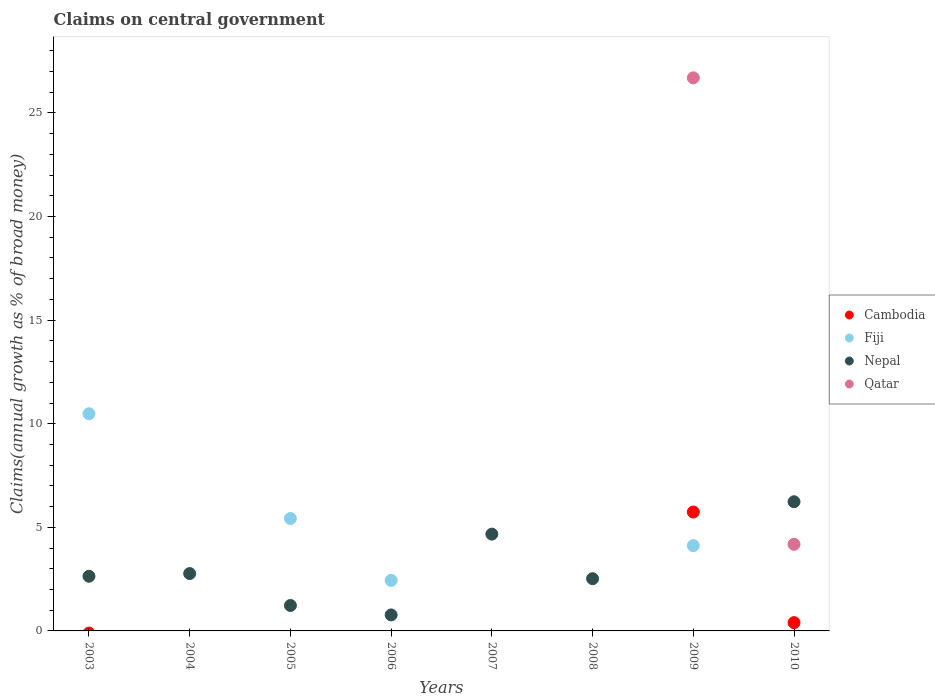Is the number of dotlines equal to the number of legend labels?
Your response must be concise. No. What is the percentage of broad money claimed on centeral government in Nepal in 2006?
Your answer should be very brief. 0.77. Across all years, what is the maximum percentage of broad money claimed on centeral government in Cambodia?
Your answer should be very brief. 5.74. Across all years, what is the minimum percentage of broad money claimed on centeral government in Fiji?
Offer a very short reply. 0. In which year was the percentage of broad money claimed on centeral government in Cambodia maximum?
Your answer should be very brief. 2009. What is the total percentage of broad money claimed on centeral government in Nepal in the graph?
Your answer should be very brief. 20.83. What is the difference between the percentage of broad money claimed on centeral government in Fiji in 2003 and that in 2009?
Offer a terse response. 6.37. What is the average percentage of broad money claimed on centeral government in Cambodia per year?
Make the answer very short. 0.77. What is the ratio of the percentage of broad money claimed on centeral government in Nepal in 2006 to that in 2007?
Offer a terse response. 0.17. What is the difference between the highest and the second highest percentage of broad money claimed on centeral government in Nepal?
Make the answer very short. 1.56. What is the difference between the highest and the lowest percentage of broad money claimed on centeral government in Cambodia?
Offer a very short reply. 5.74. Is it the case that in every year, the sum of the percentage of broad money claimed on centeral government in Qatar and percentage of broad money claimed on centeral government in Nepal  is greater than the sum of percentage of broad money claimed on centeral government in Fiji and percentage of broad money claimed on centeral government in Cambodia?
Offer a terse response. No. Does the percentage of broad money claimed on centeral government in Fiji monotonically increase over the years?
Your answer should be compact. No. Is the percentage of broad money claimed on centeral government in Nepal strictly greater than the percentage of broad money claimed on centeral government in Fiji over the years?
Your response must be concise. No. Is the percentage of broad money claimed on centeral government in Qatar strictly less than the percentage of broad money claimed on centeral government in Nepal over the years?
Keep it short and to the point. No. How many years are there in the graph?
Your answer should be very brief. 8. What is the difference between two consecutive major ticks on the Y-axis?
Your response must be concise. 5. Where does the legend appear in the graph?
Your answer should be compact. Center right. How are the legend labels stacked?
Provide a short and direct response. Vertical. What is the title of the graph?
Give a very brief answer. Claims on central government. Does "Korea (Democratic)" appear as one of the legend labels in the graph?
Offer a terse response. No. What is the label or title of the X-axis?
Ensure brevity in your answer.  Years. What is the label or title of the Y-axis?
Offer a very short reply. Claims(annual growth as % of broad money). What is the Claims(annual growth as % of broad money) in Fiji in 2003?
Give a very brief answer. 10.48. What is the Claims(annual growth as % of broad money) in Nepal in 2003?
Provide a short and direct response. 2.64. What is the Claims(annual growth as % of broad money) in Nepal in 2004?
Give a very brief answer. 2.77. What is the Claims(annual growth as % of broad money) of Qatar in 2004?
Offer a very short reply. 0. What is the Claims(annual growth as % of broad money) of Fiji in 2005?
Your answer should be compact. 5.42. What is the Claims(annual growth as % of broad money) of Nepal in 2005?
Offer a terse response. 1.23. What is the Claims(annual growth as % of broad money) of Fiji in 2006?
Offer a terse response. 2.44. What is the Claims(annual growth as % of broad money) in Nepal in 2006?
Offer a terse response. 0.77. What is the Claims(annual growth as % of broad money) in Cambodia in 2007?
Offer a terse response. 0. What is the Claims(annual growth as % of broad money) in Fiji in 2007?
Make the answer very short. 0. What is the Claims(annual growth as % of broad money) of Nepal in 2007?
Make the answer very short. 4.67. What is the Claims(annual growth as % of broad money) of Qatar in 2007?
Your response must be concise. 0. What is the Claims(annual growth as % of broad money) in Nepal in 2008?
Keep it short and to the point. 2.52. What is the Claims(annual growth as % of broad money) in Cambodia in 2009?
Ensure brevity in your answer.  5.74. What is the Claims(annual growth as % of broad money) of Fiji in 2009?
Provide a succinct answer. 4.12. What is the Claims(annual growth as % of broad money) in Nepal in 2009?
Your answer should be compact. 0. What is the Claims(annual growth as % of broad money) of Qatar in 2009?
Offer a very short reply. 26.69. What is the Claims(annual growth as % of broad money) of Cambodia in 2010?
Your answer should be very brief. 0.4. What is the Claims(annual growth as % of broad money) in Nepal in 2010?
Ensure brevity in your answer.  6.23. What is the Claims(annual growth as % of broad money) in Qatar in 2010?
Your answer should be very brief. 4.18. Across all years, what is the maximum Claims(annual growth as % of broad money) in Cambodia?
Offer a terse response. 5.74. Across all years, what is the maximum Claims(annual growth as % of broad money) of Fiji?
Offer a terse response. 10.48. Across all years, what is the maximum Claims(annual growth as % of broad money) of Nepal?
Your answer should be very brief. 6.23. Across all years, what is the maximum Claims(annual growth as % of broad money) in Qatar?
Keep it short and to the point. 26.69. Across all years, what is the minimum Claims(annual growth as % of broad money) of Cambodia?
Give a very brief answer. 0. Across all years, what is the minimum Claims(annual growth as % of broad money) in Fiji?
Offer a terse response. 0. What is the total Claims(annual growth as % of broad money) in Cambodia in the graph?
Keep it short and to the point. 6.14. What is the total Claims(annual growth as % of broad money) in Fiji in the graph?
Your answer should be very brief. 22.46. What is the total Claims(annual growth as % of broad money) of Nepal in the graph?
Provide a short and direct response. 20.83. What is the total Claims(annual growth as % of broad money) in Qatar in the graph?
Provide a succinct answer. 30.87. What is the difference between the Claims(annual growth as % of broad money) in Nepal in 2003 and that in 2004?
Your response must be concise. -0.13. What is the difference between the Claims(annual growth as % of broad money) of Fiji in 2003 and that in 2005?
Ensure brevity in your answer.  5.06. What is the difference between the Claims(annual growth as % of broad money) of Nepal in 2003 and that in 2005?
Your answer should be compact. 1.41. What is the difference between the Claims(annual growth as % of broad money) in Fiji in 2003 and that in 2006?
Keep it short and to the point. 8.04. What is the difference between the Claims(annual growth as % of broad money) in Nepal in 2003 and that in 2006?
Keep it short and to the point. 1.87. What is the difference between the Claims(annual growth as % of broad money) in Nepal in 2003 and that in 2007?
Your answer should be compact. -2.03. What is the difference between the Claims(annual growth as % of broad money) in Nepal in 2003 and that in 2008?
Offer a very short reply. 0.12. What is the difference between the Claims(annual growth as % of broad money) in Fiji in 2003 and that in 2009?
Your response must be concise. 6.37. What is the difference between the Claims(annual growth as % of broad money) of Nepal in 2003 and that in 2010?
Provide a succinct answer. -3.6. What is the difference between the Claims(annual growth as % of broad money) of Nepal in 2004 and that in 2005?
Offer a terse response. 1.54. What is the difference between the Claims(annual growth as % of broad money) in Nepal in 2004 and that in 2006?
Make the answer very short. 2. What is the difference between the Claims(annual growth as % of broad money) of Nepal in 2004 and that in 2007?
Make the answer very short. -1.9. What is the difference between the Claims(annual growth as % of broad money) of Nepal in 2004 and that in 2008?
Give a very brief answer. 0.25. What is the difference between the Claims(annual growth as % of broad money) of Nepal in 2004 and that in 2010?
Keep it short and to the point. -3.47. What is the difference between the Claims(annual growth as % of broad money) of Fiji in 2005 and that in 2006?
Offer a very short reply. 2.99. What is the difference between the Claims(annual growth as % of broad money) in Nepal in 2005 and that in 2006?
Your answer should be very brief. 0.46. What is the difference between the Claims(annual growth as % of broad money) in Nepal in 2005 and that in 2007?
Your answer should be compact. -3.44. What is the difference between the Claims(annual growth as % of broad money) in Nepal in 2005 and that in 2008?
Offer a very short reply. -1.29. What is the difference between the Claims(annual growth as % of broad money) of Fiji in 2005 and that in 2009?
Offer a very short reply. 1.31. What is the difference between the Claims(annual growth as % of broad money) of Nepal in 2005 and that in 2010?
Your response must be concise. -5.01. What is the difference between the Claims(annual growth as % of broad money) in Nepal in 2006 and that in 2007?
Provide a succinct answer. -3.9. What is the difference between the Claims(annual growth as % of broad money) in Nepal in 2006 and that in 2008?
Ensure brevity in your answer.  -1.75. What is the difference between the Claims(annual growth as % of broad money) in Fiji in 2006 and that in 2009?
Your answer should be very brief. -1.68. What is the difference between the Claims(annual growth as % of broad money) of Nepal in 2006 and that in 2010?
Keep it short and to the point. -5.46. What is the difference between the Claims(annual growth as % of broad money) in Nepal in 2007 and that in 2008?
Keep it short and to the point. 2.15. What is the difference between the Claims(annual growth as % of broad money) in Nepal in 2007 and that in 2010?
Ensure brevity in your answer.  -1.56. What is the difference between the Claims(annual growth as % of broad money) in Nepal in 2008 and that in 2010?
Ensure brevity in your answer.  -3.71. What is the difference between the Claims(annual growth as % of broad money) of Cambodia in 2009 and that in 2010?
Ensure brevity in your answer.  5.34. What is the difference between the Claims(annual growth as % of broad money) in Qatar in 2009 and that in 2010?
Provide a short and direct response. 22.51. What is the difference between the Claims(annual growth as % of broad money) of Fiji in 2003 and the Claims(annual growth as % of broad money) of Nepal in 2004?
Your answer should be very brief. 7.71. What is the difference between the Claims(annual growth as % of broad money) in Fiji in 2003 and the Claims(annual growth as % of broad money) in Nepal in 2005?
Offer a terse response. 9.25. What is the difference between the Claims(annual growth as % of broad money) in Fiji in 2003 and the Claims(annual growth as % of broad money) in Nepal in 2006?
Your answer should be compact. 9.71. What is the difference between the Claims(annual growth as % of broad money) in Fiji in 2003 and the Claims(annual growth as % of broad money) in Nepal in 2007?
Keep it short and to the point. 5.81. What is the difference between the Claims(annual growth as % of broad money) of Fiji in 2003 and the Claims(annual growth as % of broad money) of Nepal in 2008?
Offer a terse response. 7.96. What is the difference between the Claims(annual growth as % of broad money) in Fiji in 2003 and the Claims(annual growth as % of broad money) in Qatar in 2009?
Make the answer very short. -16.21. What is the difference between the Claims(annual growth as % of broad money) in Nepal in 2003 and the Claims(annual growth as % of broad money) in Qatar in 2009?
Keep it short and to the point. -24.05. What is the difference between the Claims(annual growth as % of broad money) of Fiji in 2003 and the Claims(annual growth as % of broad money) of Nepal in 2010?
Your response must be concise. 4.25. What is the difference between the Claims(annual growth as % of broad money) in Fiji in 2003 and the Claims(annual growth as % of broad money) in Qatar in 2010?
Keep it short and to the point. 6.3. What is the difference between the Claims(annual growth as % of broad money) of Nepal in 2003 and the Claims(annual growth as % of broad money) of Qatar in 2010?
Your answer should be compact. -1.54. What is the difference between the Claims(annual growth as % of broad money) of Nepal in 2004 and the Claims(annual growth as % of broad money) of Qatar in 2009?
Your answer should be very brief. -23.93. What is the difference between the Claims(annual growth as % of broad money) of Nepal in 2004 and the Claims(annual growth as % of broad money) of Qatar in 2010?
Ensure brevity in your answer.  -1.41. What is the difference between the Claims(annual growth as % of broad money) of Fiji in 2005 and the Claims(annual growth as % of broad money) of Nepal in 2006?
Keep it short and to the point. 4.65. What is the difference between the Claims(annual growth as % of broad money) of Fiji in 2005 and the Claims(annual growth as % of broad money) of Nepal in 2007?
Make the answer very short. 0.75. What is the difference between the Claims(annual growth as % of broad money) of Fiji in 2005 and the Claims(annual growth as % of broad money) of Nepal in 2008?
Your answer should be very brief. 2.9. What is the difference between the Claims(annual growth as % of broad money) in Fiji in 2005 and the Claims(annual growth as % of broad money) in Qatar in 2009?
Your response must be concise. -21.27. What is the difference between the Claims(annual growth as % of broad money) of Nepal in 2005 and the Claims(annual growth as % of broad money) of Qatar in 2009?
Your answer should be compact. -25.47. What is the difference between the Claims(annual growth as % of broad money) in Fiji in 2005 and the Claims(annual growth as % of broad money) in Nepal in 2010?
Provide a succinct answer. -0.81. What is the difference between the Claims(annual growth as % of broad money) of Fiji in 2005 and the Claims(annual growth as % of broad money) of Qatar in 2010?
Your answer should be very brief. 1.24. What is the difference between the Claims(annual growth as % of broad money) of Nepal in 2005 and the Claims(annual growth as % of broad money) of Qatar in 2010?
Make the answer very short. -2.95. What is the difference between the Claims(annual growth as % of broad money) in Fiji in 2006 and the Claims(annual growth as % of broad money) in Nepal in 2007?
Ensure brevity in your answer.  -2.23. What is the difference between the Claims(annual growth as % of broad money) in Fiji in 2006 and the Claims(annual growth as % of broad money) in Nepal in 2008?
Ensure brevity in your answer.  -0.08. What is the difference between the Claims(annual growth as % of broad money) of Fiji in 2006 and the Claims(annual growth as % of broad money) of Qatar in 2009?
Your answer should be compact. -24.25. What is the difference between the Claims(annual growth as % of broad money) of Nepal in 2006 and the Claims(annual growth as % of broad money) of Qatar in 2009?
Ensure brevity in your answer.  -25.92. What is the difference between the Claims(annual growth as % of broad money) in Fiji in 2006 and the Claims(annual growth as % of broad money) in Nepal in 2010?
Give a very brief answer. -3.8. What is the difference between the Claims(annual growth as % of broad money) in Fiji in 2006 and the Claims(annual growth as % of broad money) in Qatar in 2010?
Provide a succinct answer. -1.74. What is the difference between the Claims(annual growth as % of broad money) of Nepal in 2006 and the Claims(annual growth as % of broad money) of Qatar in 2010?
Your response must be concise. -3.41. What is the difference between the Claims(annual growth as % of broad money) of Nepal in 2007 and the Claims(annual growth as % of broad money) of Qatar in 2009?
Make the answer very short. -22.02. What is the difference between the Claims(annual growth as % of broad money) of Nepal in 2007 and the Claims(annual growth as % of broad money) of Qatar in 2010?
Ensure brevity in your answer.  0.49. What is the difference between the Claims(annual growth as % of broad money) in Nepal in 2008 and the Claims(annual growth as % of broad money) in Qatar in 2009?
Give a very brief answer. -24.17. What is the difference between the Claims(annual growth as % of broad money) in Nepal in 2008 and the Claims(annual growth as % of broad money) in Qatar in 2010?
Provide a succinct answer. -1.66. What is the difference between the Claims(annual growth as % of broad money) in Cambodia in 2009 and the Claims(annual growth as % of broad money) in Nepal in 2010?
Your response must be concise. -0.5. What is the difference between the Claims(annual growth as % of broad money) of Cambodia in 2009 and the Claims(annual growth as % of broad money) of Qatar in 2010?
Your answer should be very brief. 1.56. What is the difference between the Claims(annual growth as % of broad money) in Fiji in 2009 and the Claims(annual growth as % of broad money) in Nepal in 2010?
Offer a terse response. -2.12. What is the difference between the Claims(annual growth as % of broad money) in Fiji in 2009 and the Claims(annual growth as % of broad money) in Qatar in 2010?
Ensure brevity in your answer.  -0.06. What is the average Claims(annual growth as % of broad money) in Cambodia per year?
Offer a terse response. 0.77. What is the average Claims(annual growth as % of broad money) of Fiji per year?
Offer a very short reply. 2.81. What is the average Claims(annual growth as % of broad money) in Nepal per year?
Provide a short and direct response. 2.6. What is the average Claims(annual growth as % of broad money) of Qatar per year?
Make the answer very short. 3.86. In the year 2003, what is the difference between the Claims(annual growth as % of broad money) of Fiji and Claims(annual growth as % of broad money) of Nepal?
Offer a terse response. 7.84. In the year 2005, what is the difference between the Claims(annual growth as % of broad money) in Fiji and Claims(annual growth as % of broad money) in Nepal?
Provide a short and direct response. 4.2. In the year 2006, what is the difference between the Claims(annual growth as % of broad money) in Fiji and Claims(annual growth as % of broad money) in Nepal?
Your answer should be compact. 1.67. In the year 2009, what is the difference between the Claims(annual growth as % of broad money) of Cambodia and Claims(annual growth as % of broad money) of Fiji?
Give a very brief answer. 1.62. In the year 2009, what is the difference between the Claims(annual growth as % of broad money) of Cambodia and Claims(annual growth as % of broad money) of Qatar?
Offer a terse response. -20.96. In the year 2009, what is the difference between the Claims(annual growth as % of broad money) in Fiji and Claims(annual growth as % of broad money) in Qatar?
Your answer should be very brief. -22.58. In the year 2010, what is the difference between the Claims(annual growth as % of broad money) of Cambodia and Claims(annual growth as % of broad money) of Nepal?
Provide a short and direct response. -5.83. In the year 2010, what is the difference between the Claims(annual growth as % of broad money) in Cambodia and Claims(annual growth as % of broad money) in Qatar?
Offer a very short reply. -3.78. In the year 2010, what is the difference between the Claims(annual growth as % of broad money) in Nepal and Claims(annual growth as % of broad money) in Qatar?
Make the answer very short. 2.05. What is the ratio of the Claims(annual growth as % of broad money) in Nepal in 2003 to that in 2004?
Your answer should be very brief. 0.95. What is the ratio of the Claims(annual growth as % of broad money) in Fiji in 2003 to that in 2005?
Provide a succinct answer. 1.93. What is the ratio of the Claims(annual growth as % of broad money) of Nepal in 2003 to that in 2005?
Your answer should be compact. 2.15. What is the ratio of the Claims(annual growth as % of broad money) in Fiji in 2003 to that in 2006?
Your answer should be very brief. 4.3. What is the ratio of the Claims(annual growth as % of broad money) of Nepal in 2003 to that in 2006?
Your response must be concise. 3.42. What is the ratio of the Claims(annual growth as % of broad money) of Nepal in 2003 to that in 2007?
Your answer should be compact. 0.56. What is the ratio of the Claims(annual growth as % of broad money) of Nepal in 2003 to that in 2008?
Your answer should be compact. 1.05. What is the ratio of the Claims(annual growth as % of broad money) in Fiji in 2003 to that in 2009?
Your answer should be compact. 2.55. What is the ratio of the Claims(annual growth as % of broad money) of Nepal in 2003 to that in 2010?
Provide a short and direct response. 0.42. What is the ratio of the Claims(annual growth as % of broad money) in Nepal in 2004 to that in 2005?
Provide a short and direct response. 2.25. What is the ratio of the Claims(annual growth as % of broad money) in Nepal in 2004 to that in 2006?
Keep it short and to the point. 3.58. What is the ratio of the Claims(annual growth as % of broad money) of Nepal in 2004 to that in 2007?
Your answer should be very brief. 0.59. What is the ratio of the Claims(annual growth as % of broad money) in Nepal in 2004 to that in 2008?
Make the answer very short. 1.1. What is the ratio of the Claims(annual growth as % of broad money) of Nepal in 2004 to that in 2010?
Keep it short and to the point. 0.44. What is the ratio of the Claims(annual growth as % of broad money) in Fiji in 2005 to that in 2006?
Ensure brevity in your answer.  2.22. What is the ratio of the Claims(annual growth as % of broad money) of Nepal in 2005 to that in 2006?
Ensure brevity in your answer.  1.59. What is the ratio of the Claims(annual growth as % of broad money) of Nepal in 2005 to that in 2007?
Give a very brief answer. 0.26. What is the ratio of the Claims(annual growth as % of broad money) in Nepal in 2005 to that in 2008?
Ensure brevity in your answer.  0.49. What is the ratio of the Claims(annual growth as % of broad money) of Fiji in 2005 to that in 2009?
Your answer should be very brief. 1.32. What is the ratio of the Claims(annual growth as % of broad money) of Nepal in 2005 to that in 2010?
Make the answer very short. 0.2. What is the ratio of the Claims(annual growth as % of broad money) in Nepal in 2006 to that in 2007?
Ensure brevity in your answer.  0.17. What is the ratio of the Claims(annual growth as % of broad money) in Nepal in 2006 to that in 2008?
Provide a short and direct response. 0.31. What is the ratio of the Claims(annual growth as % of broad money) in Fiji in 2006 to that in 2009?
Offer a very short reply. 0.59. What is the ratio of the Claims(annual growth as % of broad money) in Nepal in 2006 to that in 2010?
Keep it short and to the point. 0.12. What is the ratio of the Claims(annual growth as % of broad money) in Nepal in 2007 to that in 2008?
Offer a terse response. 1.85. What is the ratio of the Claims(annual growth as % of broad money) in Nepal in 2007 to that in 2010?
Your answer should be very brief. 0.75. What is the ratio of the Claims(annual growth as % of broad money) of Nepal in 2008 to that in 2010?
Make the answer very short. 0.4. What is the ratio of the Claims(annual growth as % of broad money) in Cambodia in 2009 to that in 2010?
Provide a short and direct response. 14.33. What is the ratio of the Claims(annual growth as % of broad money) of Qatar in 2009 to that in 2010?
Provide a short and direct response. 6.39. What is the difference between the highest and the second highest Claims(annual growth as % of broad money) in Fiji?
Make the answer very short. 5.06. What is the difference between the highest and the second highest Claims(annual growth as % of broad money) of Nepal?
Provide a short and direct response. 1.56. What is the difference between the highest and the lowest Claims(annual growth as % of broad money) in Cambodia?
Give a very brief answer. 5.74. What is the difference between the highest and the lowest Claims(annual growth as % of broad money) in Fiji?
Your answer should be compact. 10.48. What is the difference between the highest and the lowest Claims(annual growth as % of broad money) in Nepal?
Ensure brevity in your answer.  6.23. What is the difference between the highest and the lowest Claims(annual growth as % of broad money) of Qatar?
Offer a terse response. 26.69. 